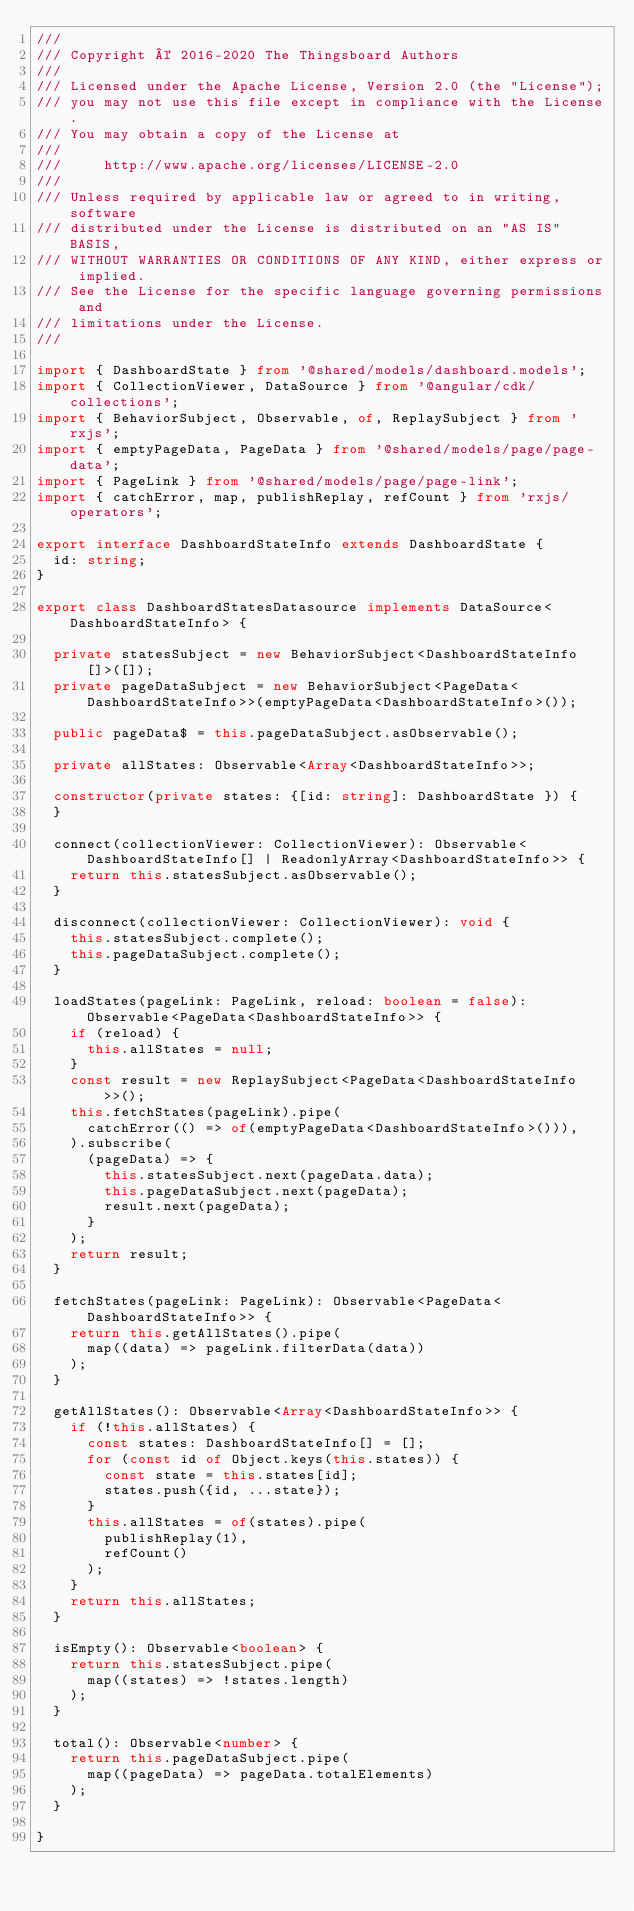Convert code to text. <code><loc_0><loc_0><loc_500><loc_500><_TypeScript_>///
/// Copyright © 2016-2020 The Thingsboard Authors
///
/// Licensed under the Apache License, Version 2.0 (the "License");
/// you may not use this file except in compliance with the License.
/// You may obtain a copy of the License at
///
///     http://www.apache.org/licenses/LICENSE-2.0
///
/// Unless required by applicable law or agreed to in writing, software
/// distributed under the License is distributed on an "AS IS" BASIS,
/// WITHOUT WARRANTIES OR CONDITIONS OF ANY KIND, either express or implied.
/// See the License for the specific language governing permissions and
/// limitations under the License.
///

import { DashboardState } from '@shared/models/dashboard.models';
import { CollectionViewer, DataSource } from '@angular/cdk/collections';
import { BehaviorSubject, Observable, of, ReplaySubject } from 'rxjs';
import { emptyPageData, PageData } from '@shared/models/page/page-data';
import { PageLink } from '@shared/models/page/page-link';
import { catchError, map, publishReplay, refCount } from 'rxjs/operators';

export interface DashboardStateInfo extends DashboardState {
  id: string;
}

export class DashboardStatesDatasource implements DataSource<DashboardStateInfo> {

  private statesSubject = new BehaviorSubject<DashboardStateInfo[]>([]);
  private pageDataSubject = new BehaviorSubject<PageData<DashboardStateInfo>>(emptyPageData<DashboardStateInfo>());

  public pageData$ = this.pageDataSubject.asObservable();

  private allStates: Observable<Array<DashboardStateInfo>>;

  constructor(private states: {[id: string]: DashboardState }) {
  }

  connect(collectionViewer: CollectionViewer): Observable<DashboardStateInfo[] | ReadonlyArray<DashboardStateInfo>> {
    return this.statesSubject.asObservable();
  }

  disconnect(collectionViewer: CollectionViewer): void {
    this.statesSubject.complete();
    this.pageDataSubject.complete();
  }

  loadStates(pageLink: PageLink, reload: boolean = false): Observable<PageData<DashboardStateInfo>> {
    if (reload) {
      this.allStates = null;
    }
    const result = new ReplaySubject<PageData<DashboardStateInfo>>();
    this.fetchStates(pageLink).pipe(
      catchError(() => of(emptyPageData<DashboardStateInfo>())),
    ).subscribe(
      (pageData) => {
        this.statesSubject.next(pageData.data);
        this.pageDataSubject.next(pageData);
        result.next(pageData);
      }
    );
    return result;
  }

  fetchStates(pageLink: PageLink): Observable<PageData<DashboardStateInfo>> {
    return this.getAllStates().pipe(
      map((data) => pageLink.filterData(data))
    );
  }

  getAllStates(): Observable<Array<DashboardStateInfo>> {
    if (!this.allStates) {
      const states: DashboardStateInfo[] = [];
      for (const id of Object.keys(this.states)) {
        const state = this.states[id];
        states.push({id, ...state});
      }
      this.allStates = of(states).pipe(
        publishReplay(1),
        refCount()
      );
    }
    return this.allStates;
  }

  isEmpty(): Observable<boolean> {
    return this.statesSubject.pipe(
      map((states) => !states.length)
    );
  }

  total(): Observable<number> {
    return this.pageDataSubject.pipe(
      map((pageData) => pageData.totalElements)
    );
  }

}
</code> 